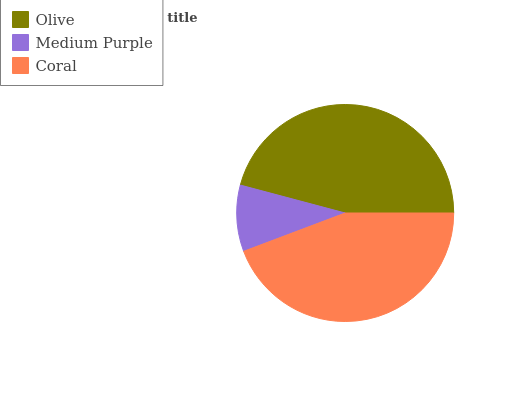Is Medium Purple the minimum?
Answer yes or no. Yes. Is Olive the maximum?
Answer yes or no. Yes. Is Coral the minimum?
Answer yes or no. No. Is Coral the maximum?
Answer yes or no. No. Is Coral greater than Medium Purple?
Answer yes or no. Yes. Is Medium Purple less than Coral?
Answer yes or no. Yes. Is Medium Purple greater than Coral?
Answer yes or no. No. Is Coral less than Medium Purple?
Answer yes or no. No. Is Coral the high median?
Answer yes or no. Yes. Is Coral the low median?
Answer yes or no. Yes. Is Medium Purple the high median?
Answer yes or no. No. Is Olive the low median?
Answer yes or no. No. 